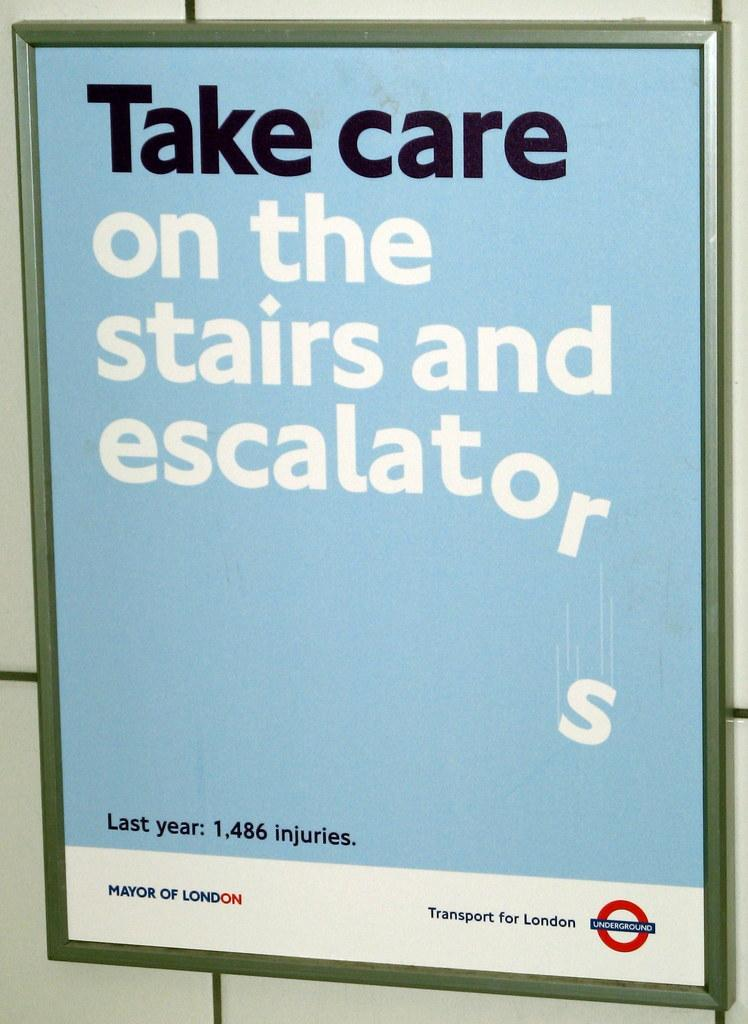<image>
Offer a succinct explanation of the picture presented. a sign that says to take care on stairs 